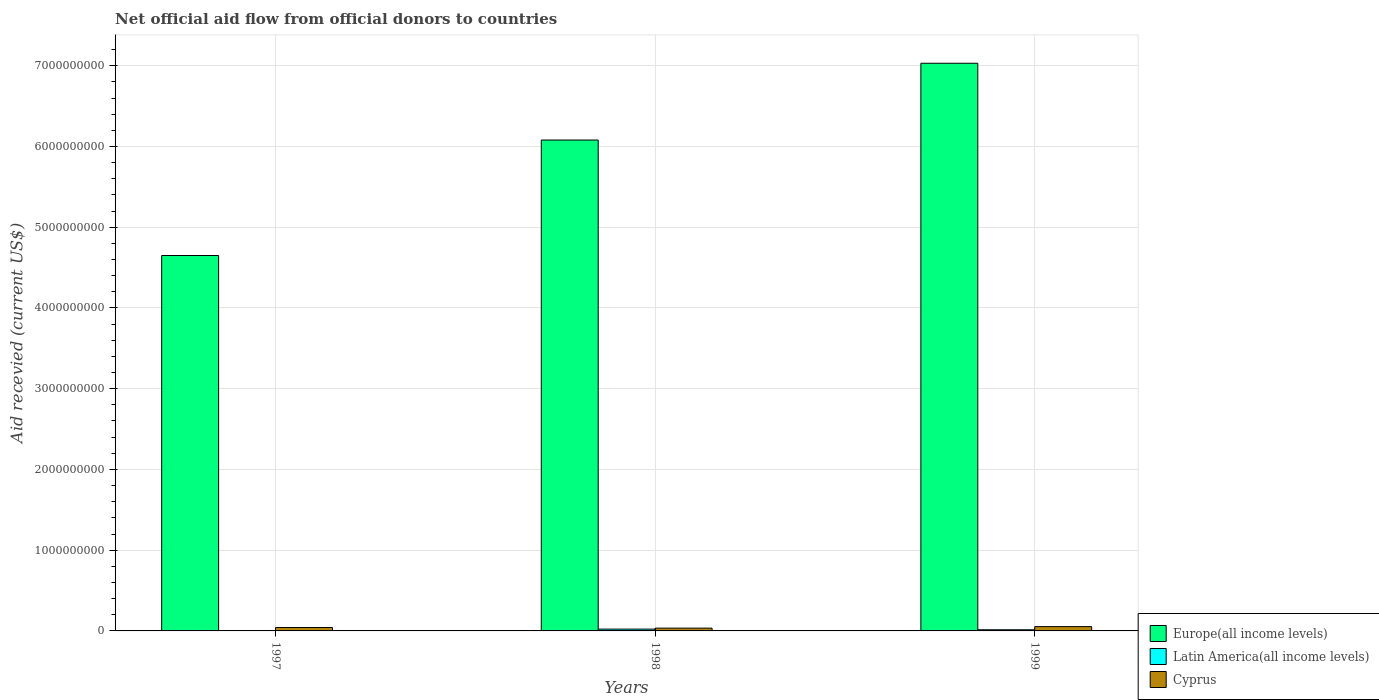Are the number of bars per tick equal to the number of legend labels?
Your answer should be very brief. No. How many bars are there on the 3rd tick from the left?
Provide a short and direct response. 3. What is the label of the 2nd group of bars from the left?
Offer a terse response. 1998. What is the total aid received in Cyprus in 1997?
Your response must be concise. 4.22e+07. Across all years, what is the maximum total aid received in Latin America(all income levels)?
Provide a succinct answer. 2.25e+07. Across all years, what is the minimum total aid received in Europe(all income levels)?
Your answer should be very brief. 4.65e+09. What is the total total aid received in Europe(all income levels) in the graph?
Your answer should be very brief. 1.78e+1. What is the difference between the total aid received in Cyprus in 1997 and that in 1998?
Your response must be concise. 7.69e+06. What is the difference between the total aid received in Latin America(all income levels) in 1997 and the total aid received in Cyprus in 1999?
Provide a succinct answer. -5.33e+07. What is the average total aid received in Latin America(all income levels) per year?
Keep it short and to the point. 1.23e+07. In the year 1997, what is the difference between the total aid received in Cyprus and total aid received in Europe(all income levels)?
Offer a very short reply. -4.61e+09. What is the ratio of the total aid received in Cyprus in 1998 to that in 1999?
Your response must be concise. 0.65. Is the total aid received in Europe(all income levels) in 1997 less than that in 1998?
Provide a succinct answer. Yes. Is the difference between the total aid received in Cyprus in 1997 and 1998 greater than the difference between the total aid received in Europe(all income levels) in 1997 and 1998?
Make the answer very short. Yes. What is the difference between the highest and the second highest total aid received in Cyprus?
Give a very brief answer. 1.11e+07. What is the difference between the highest and the lowest total aid received in Latin America(all income levels)?
Offer a very short reply. 2.25e+07. In how many years, is the total aid received in Europe(all income levels) greater than the average total aid received in Europe(all income levels) taken over all years?
Keep it short and to the point. 2. How many bars are there?
Offer a very short reply. 8. Where does the legend appear in the graph?
Your answer should be very brief. Bottom right. How many legend labels are there?
Ensure brevity in your answer.  3. How are the legend labels stacked?
Your response must be concise. Vertical. What is the title of the graph?
Give a very brief answer. Net official aid flow from official donors to countries. Does "Sub-Saharan Africa (developing only)" appear as one of the legend labels in the graph?
Keep it short and to the point. No. What is the label or title of the Y-axis?
Offer a terse response. Aid recevied (current US$). What is the Aid recevied (current US$) of Europe(all income levels) in 1997?
Your response must be concise. 4.65e+09. What is the Aid recevied (current US$) in Latin America(all income levels) in 1997?
Ensure brevity in your answer.  0. What is the Aid recevied (current US$) of Cyprus in 1997?
Offer a terse response. 4.22e+07. What is the Aid recevied (current US$) in Europe(all income levels) in 1998?
Give a very brief answer. 6.08e+09. What is the Aid recevied (current US$) in Latin America(all income levels) in 1998?
Make the answer very short. 2.25e+07. What is the Aid recevied (current US$) of Cyprus in 1998?
Provide a succinct answer. 3.45e+07. What is the Aid recevied (current US$) of Europe(all income levels) in 1999?
Provide a short and direct response. 7.03e+09. What is the Aid recevied (current US$) of Latin America(all income levels) in 1999?
Provide a short and direct response. 1.43e+07. What is the Aid recevied (current US$) of Cyprus in 1999?
Make the answer very short. 5.33e+07. Across all years, what is the maximum Aid recevied (current US$) in Europe(all income levels)?
Provide a short and direct response. 7.03e+09. Across all years, what is the maximum Aid recevied (current US$) in Latin America(all income levels)?
Make the answer very short. 2.25e+07. Across all years, what is the maximum Aid recevied (current US$) of Cyprus?
Provide a short and direct response. 5.33e+07. Across all years, what is the minimum Aid recevied (current US$) of Europe(all income levels)?
Offer a terse response. 4.65e+09. Across all years, what is the minimum Aid recevied (current US$) of Latin America(all income levels)?
Give a very brief answer. 0. Across all years, what is the minimum Aid recevied (current US$) in Cyprus?
Ensure brevity in your answer.  3.45e+07. What is the total Aid recevied (current US$) of Europe(all income levels) in the graph?
Keep it short and to the point. 1.78e+1. What is the total Aid recevied (current US$) of Latin America(all income levels) in the graph?
Keep it short and to the point. 3.69e+07. What is the total Aid recevied (current US$) of Cyprus in the graph?
Provide a succinct answer. 1.30e+08. What is the difference between the Aid recevied (current US$) in Europe(all income levels) in 1997 and that in 1998?
Your answer should be compact. -1.43e+09. What is the difference between the Aid recevied (current US$) in Cyprus in 1997 and that in 1998?
Your answer should be very brief. 7.69e+06. What is the difference between the Aid recevied (current US$) of Europe(all income levels) in 1997 and that in 1999?
Ensure brevity in your answer.  -2.38e+09. What is the difference between the Aid recevied (current US$) in Cyprus in 1997 and that in 1999?
Provide a succinct answer. -1.11e+07. What is the difference between the Aid recevied (current US$) of Europe(all income levels) in 1998 and that in 1999?
Your answer should be very brief. -9.51e+08. What is the difference between the Aid recevied (current US$) of Latin America(all income levels) in 1998 and that in 1999?
Make the answer very short. 8.20e+06. What is the difference between the Aid recevied (current US$) of Cyprus in 1998 and that in 1999?
Give a very brief answer. -1.88e+07. What is the difference between the Aid recevied (current US$) in Europe(all income levels) in 1997 and the Aid recevied (current US$) in Latin America(all income levels) in 1998?
Provide a short and direct response. 4.63e+09. What is the difference between the Aid recevied (current US$) in Europe(all income levels) in 1997 and the Aid recevied (current US$) in Cyprus in 1998?
Make the answer very short. 4.61e+09. What is the difference between the Aid recevied (current US$) of Europe(all income levels) in 1997 and the Aid recevied (current US$) of Latin America(all income levels) in 1999?
Offer a very short reply. 4.64e+09. What is the difference between the Aid recevied (current US$) of Europe(all income levels) in 1997 and the Aid recevied (current US$) of Cyprus in 1999?
Provide a succinct answer. 4.60e+09. What is the difference between the Aid recevied (current US$) of Europe(all income levels) in 1998 and the Aid recevied (current US$) of Latin America(all income levels) in 1999?
Provide a succinct answer. 6.07e+09. What is the difference between the Aid recevied (current US$) of Europe(all income levels) in 1998 and the Aid recevied (current US$) of Cyprus in 1999?
Offer a very short reply. 6.03e+09. What is the difference between the Aid recevied (current US$) of Latin America(all income levels) in 1998 and the Aid recevied (current US$) of Cyprus in 1999?
Provide a short and direct response. -3.08e+07. What is the average Aid recevied (current US$) of Europe(all income levels) per year?
Your response must be concise. 5.92e+09. What is the average Aid recevied (current US$) of Latin America(all income levels) per year?
Your answer should be very brief. 1.23e+07. What is the average Aid recevied (current US$) of Cyprus per year?
Make the answer very short. 4.34e+07. In the year 1997, what is the difference between the Aid recevied (current US$) of Europe(all income levels) and Aid recevied (current US$) of Cyprus?
Offer a terse response. 4.61e+09. In the year 1998, what is the difference between the Aid recevied (current US$) in Europe(all income levels) and Aid recevied (current US$) in Latin America(all income levels)?
Your answer should be very brief. 6.06e+09. In the year 1998, what is the difference between the Aid recevied (current US$) of Europe(all income levels) and Aid recevied (current US$) of Cyprus?
Your answer should be compact. 6.04e+09. In the year 1998, what is the difference between the Aid recevied (current US$) of Latin America(all income levels) and Aid recevied (current US$) of Cyprus?
Ensure brevity in your answer.  -1.20e+07. In the year 1999, what is the difference between the Aid recevied (current US$) in Europe(all income levels) and Aid recevied (current US$) in Latin America(all income levels)?
Ensure brevity in your answer.  7.02e+09. In the year 1999, what is the difference between the Aid recevied (current US$) in Europe(all income levels) and Aid recevied (current US$) in Cyprus?
Keep it short and to the point. 6.98e+09. In the year 1999, what is the difference between the Aid recevied (current US$) in Latin America(all income levels) and Aid recevied (current US$) in Cyprus?
Give a very brief answer. -3.90e+07. What is the ratio of the Aid recevied (current US$) in Europe(all income levels) in 1997 to that in 1998?
Provide a short and direct response. 0.76. What is the ratio of the Aid recevied (current US$) of Cyprus in 1997 to that in 1998?
Offer a terse response. 1.22. What is the ratio of the Aid recevied (current US$) of Europe(all income levels) in 1997 to that in 1999?
Provide a succinct answer. 0.66. What is the ratio of the Aid recevied (current US$) of Cyprus in 1997 to that in 1999?
Give a very brief answer. 0.79. What is the ratio of the Aid recevied (current US$) of Europe(all income levels) in 1998 to that in 1999?
Give a very brief answer. 0.86. What is the ratio of the Aid recevied (current US$) in Latin America(all income levels) in 1998 to that in 1999?
Your response must be concise. 1.57. What is the ratio of the Aid recevied (current US$) in Cyprus in 1998 to that in 1999?
Your response must be concise. 0.65. What is the difference between the highest and the second highest Aid recevied (current US$) of Europe(all income levels)?
Provide a succinct answer. 9.51e+08. What is the difference between the highest and the second highest Aid recevied (current US$) of Cyprus?
Offer a very short reply. 1.11e+07. What is the difference between the highest and the lowest Aid recevied (current US$) in Europe(all income levels)?
Provide a succinct answer. 2.38e+09. What is the difference between the highest and the lowest Aid recevied (current US$) in Latin America(all income levels)?
Your response must be concise. 2.25e+07. What is the difference between the highest and the lowest Aid recevied (current US$) of Cyprus?
Offer a very short reply. 1.88e+07. 